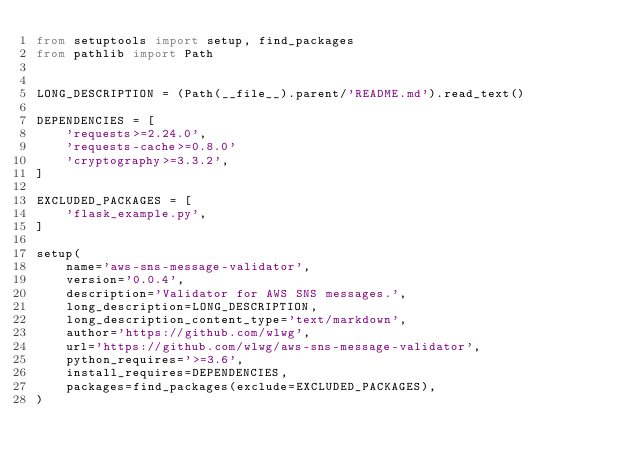<code> <loc_0><loc_0><loc_500><loc_500><_Python_>from setuptools import setup, find_packages
from pathlib import Path


LONG_DESCRIPTION = (Path(__file__).parent/'README.md').read_text()

DEPENDENCIES = [
    'requests>=2.24.0',
    'requests-cache>=0.8.0'
    'cryptography>=3.3.2',
]

EXCLUDED_PACKAGES = [
    'flask_example.py',
]

setup(
    name='aws-sns-message-validator',
    version='0.0.4',
    description='Validator for AWS SNS messages.',
    long_description=LONG_DESCRIPTION,
    long_description_content_type='text/markdown',
    author='https://github.com/wlwg',
    url='https://github.com/wlwg/aws-sns-message-validator',
    python_requires='>=3.6',
    install_requires=DEPENDENCIES,
    packages=find_packages(exclude=EXCLUDED_PACKAGES),
)
</code> 